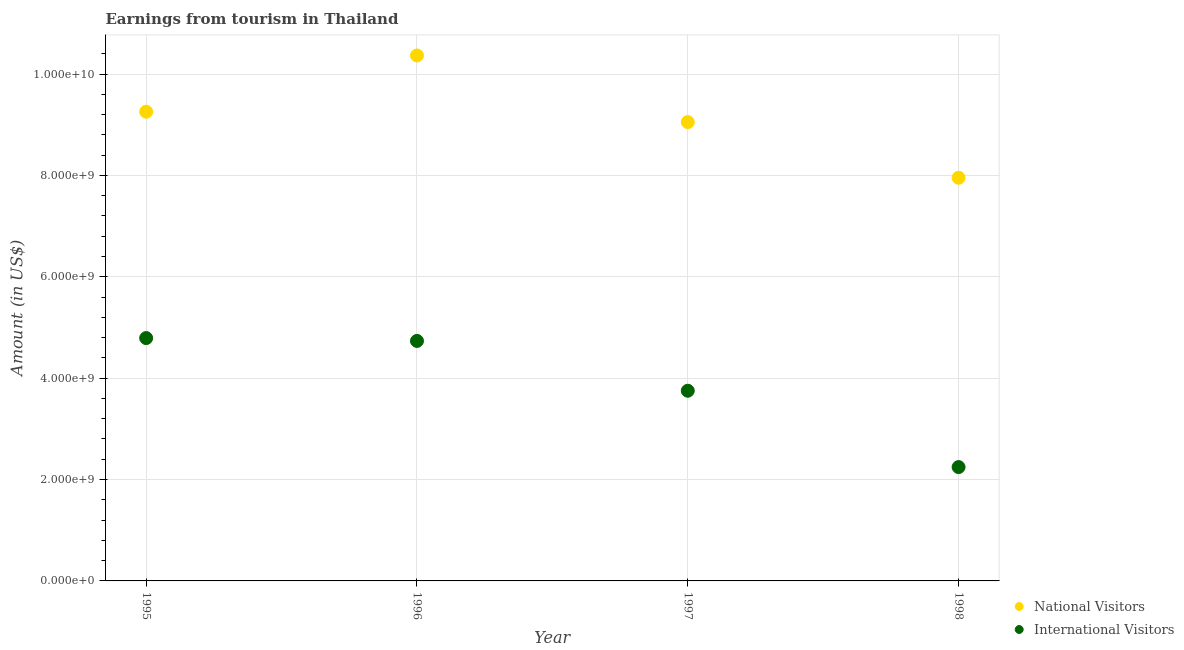How many different coloured dotlines are there?
Offer a very short reply. 2. What is the amount earned from international visitors in 1997?
Ensure brevity in your answer.  3.75e+09. Across all years, what is the maximum amount earned from international visitors?
Provide a short and direct response. 4.79e+09. Across all years, what is the minimum amount earned from international visitors?
Ensure brevity in your answer.  2.25e+09. What is the total amount earned from national visitors in the graph?
Your answer should be very brief. 3.66e+1. What is the difference between the amount earned from national visitors in 1995 and that in 1997?
Provide a succinct answer. 2.05e+08. What is the difference between the amount earned from national visitors in 1997 and the amount earned from international visitors in 1995?
Give a very brief answer. 4.26e+09. What is the average amount earned from international visitors per year?
Your response must be concise. 3.88e+09. In the year 1997, what is the difference between the amount earned from national visitors and amount earned from international visitors?
Provide a succinct answer. 5.30e+09. What is the ratio of the amount earned from national visitors in 1995 to that in 1997?
Give a very brief answer. 1.02. What is the difference between the highest and the second highest amount earned from national visitors?
Your answer should be compact. 1.11e+09. What is the difference between the highest and the lowest amount earned from international visitors?
Make the answer very short. 2.54e+09. In how many years, is the amount earned from national visitors greater than the average amount earned from national visitors taken over all years?
Offer a very short reply. 2. Is the sum of the amount earned from international visitors in 1996 and 1998 greater than the maximum amount earned from national visitors across all years?
Offer a very short reply. No. Is the amount earned from national visitors strictly greater than the amount earned from international visitors over the years?
Offer a terse response. Yes. Is the amount earned from international visitors strictly less than the amount earned from national visitors over the years?
Your answer should be very brief. Yes. What is the difference between two consecutive major ticks on the Y-axis?
Provide a succinct answer. 2.00e+09. Are the values on the major ticks of Y-axis written in scientific E-notation?
Your answer should be compact. Yes. Does the graph contain any zero values?
Offer a terse response. No. How are the legend labels stacked?
Ensure brevity in your answer.  Vertical. What is the title of the graph?
Offer a very short reply. Earnings from tourism in Thailand. Does "From World Bank" appear as one of the legend labels in the graph?
Your response must be concise. No. What is the label or title of the X-axis?
Your answer should be compact. Year. What is the Amount (in US$) of National Visitors in 1995?
Ensure brevity in your answer.  9.26e+09. What is the Amount (in US$) of International Visitors in 1995?
Your answer should be compact. 4.79e+09. What is the Amount (in US$) of National Visitors in 1996?
Offer a terse response. 1.04e+1. What is the Amount (in US$) of International Visitors in 1996?
Give a very brief answer. 4.74e+09. What is the Amount (in US$) of National Visitors in 1997?
Provide a short and direct response. 9.05e+09. What is the Amount (in US$) in International Visitors in 1997?
Provide a short and direct response. 3.75e+09. What is the Amount (in US$) of National Visitors in 1998?
Ensure brevity in your answer.  7.95e+09. What is the Amount (in US$) of International Visitors in 1998?
Offer a terse response. 2.25e+09. Across all years, what is the maximum Amount (in US$) in National Visitors?
Make the answer very short. 1.04e+1. Across all years, what is the maximum Amount (in US$) of International Visitors?
Give a very brief answer. 4.79e+09. Across all years, what is the minimum Amount (in US$) of National Visitors?
Keep it short and to the point. 7.95e+09. Across all years, what is the minimum Amount (in US$) in International Visitors?
Offer a terse response. 2.25e+09. What is the total Amount (in US$) in National Visitors in the graph?
Your answer should be very brief. 3.66e+1. What is the total Amount (in US$) of International Visitors in the graph?
Your response must be concise. 1.55e+1. What is the difference between the Amount (in US$) of National Visitors in 1995 and that in 1996?
Give a very brief answer. -1.11e+09. What is the difference between the Amount (in US$) of International Visitors in 1995 and that in 1996?
Make the answer very short. 5.60e+07. What is the difference between the Amount (in US$) in National Visitors in 1995 and that in 1997?
Provide a short and direct response. 2.05e+08. What is the difference between the Amount (in US$) in International Visitors in 1995 and that in 1997?
Your response must be concise. 1.04e+09. What is the difference between the Amount (in US$) in National Visitors in 1995 and that in 1998?
Provide a short and direct response. 1.30e+09. What is the difference between the Amount (in US$) in International Visitors in 1995 and that in 1998?
Keep it short and to the point. 2.54e+09. What is the difference between the Amount (in US$) in National Visitors in 1996 and that in 1997?
Your answer should be compact. 1.32e+09. What is the difference between the Amount (in US$) of International Visitors in 1996 and that in 1997?
Provide a succinct answer. 9.83e+08. What is the difference between the Amount (in US$) in National Visitors in 1996 and that in 1998?
Give a very brief answer. 2.41e+09. What is the difference between the Amount (in US$) of International Visitors in 1996 and that in 1998?
Provide a short and direct response. 2.49e+09. What is the difference between the Amount (in US$) in National Visitors in 1997 and that in 1998?
Give a very brief answer. 1.10e+09. What is the difference between the Amount (in US$) of International Visitors in 1997 and that in 1998?
Your answer should be compact. 1.51e+09. What is the difference between the Amount (in US$) of National Visitors in 1995 and the Amount (in US$) of International Visitors in 1996?
Offer a very short reply. 4.52e+09. What is the difference between the Amount (in US$) in National Visitors in 1995 and the Amount (in US$) in International Visitors in 1997?
Keep it short and to the point. 5.50e+09. What is the difference between the Amount (in US$) of National Visitors in 1995 and the Amount (in US$) of International Visitors in 1998?
Your answer should be compact. 7.01e+09. What is the difference between the Amount (in US$) in National Visitors in 1996 and the Amount (in US$) in International Visitors in 1997?
Keep it short and to the point. 6.62e+09. What is the difference between the Amount (in US$) in National Visitors in 1996 and the Amount (in US$) in International Visitors in 1998?
Your response must be concise. 8.12e+09. What is the difference between the Amount (in US$) of National Visitors in 1997 and the Amount (in US$) of International Visitors in 1998?
Your response must be concise. 6.81e+09. What is the average Amount (in US$) in National Visitors per year?
Make the answer very short. 9.16e+09. What is the average Amount (in US$) in International Visitors per year?
Offer a terse response. 3.88e+09. In the year 1995, what is the difference between the Amount (in US$) of National Visitors and Amount (in US$) of International Visitors?
Your response must be concise. 4.47e+09. In the year 1996, what is the difference between the Amount (in US$) of National Visitors and Amount (in US$) of International Visitors?
Provide a short and direct response. 5.63e+09. In the year 1997, what is the difference between the Amount (in US$) of National Visitors and Amount (in US$) of International Visitors?
Give a very brief answer. 5.30e+09. In the year 1998, what is the difference between the Amount (in US$) in National Visitors and Amount (in US$) in International Visitors?
Provide a short and direct response. 5.71e+09. What is the ratio of the Amount (in US$) in National Visitors in 1995 to that in 1996?
Ensure brevity in your answer.  0.89. What is the ratio of the Amount (in US$) of International Visitors in 1995 to that in 1996?
Offer a terse response. 1.01. What is the ratio of the Amount (in US$) in National Visitors in 1995 to that in 1997?
Your answer should be compact. 1.02. What is the ratio of the Amount (in US$) in International Visitors in 1995 to that in 1997?
Your response must be concise. 1.28. What is the ratio of the Amount (in US$) in National Visitors in 1995 to that in 1998?
Provide a succinct answer. 1.16. What is the ratio of the Amount (in US$) of International Visitors in 1995 to that in 1998?
Give a very brief answer. 2.13. What is the ratio of the Amount (in US$) of National Visitors in 1996 to that in 1997?
Provide a short and direct response. 1.15. What is the ratio of the Amount (in US$) in International Visitors in 1996 to that in 1997?
Your answer should be very brief. 1.26. What is the ratio of the Amount (in US$) of National Visitors in 1996 to that in 1998?
Make the answer very short. 1.3. What is the ratio of the Amount (in US$) in International Visitors in 1996 to that in 1998?
Your answer should be very brief. 2.11. What is the ratio of the Amount (in US$) of National Visitors in 1997 to that in 1998?
Give a very brief answer. 1.14. What is the ratio of the Amount (in US$) in International Visitors in 1997 to that in 1998?
Ensure brevity in your answer.  1.67. What is the difference between the highest and the second highest Amount (in US$) of National Visitors?
Your response must be concise. 1.11e+09. What is the difference between the highest and the second highest Amount (in US$) of International Visitors?
Your answer should be compact. 5.60e+07. What is the difference between the highest and the lowest Amount (in US$) in National Visitors?
Provide a short and direct response. 2.41e+09. What is the difference between the highest and the lowest Amount (in US$) in International Visitors?
Make the answer very short. 2.54e+09. 